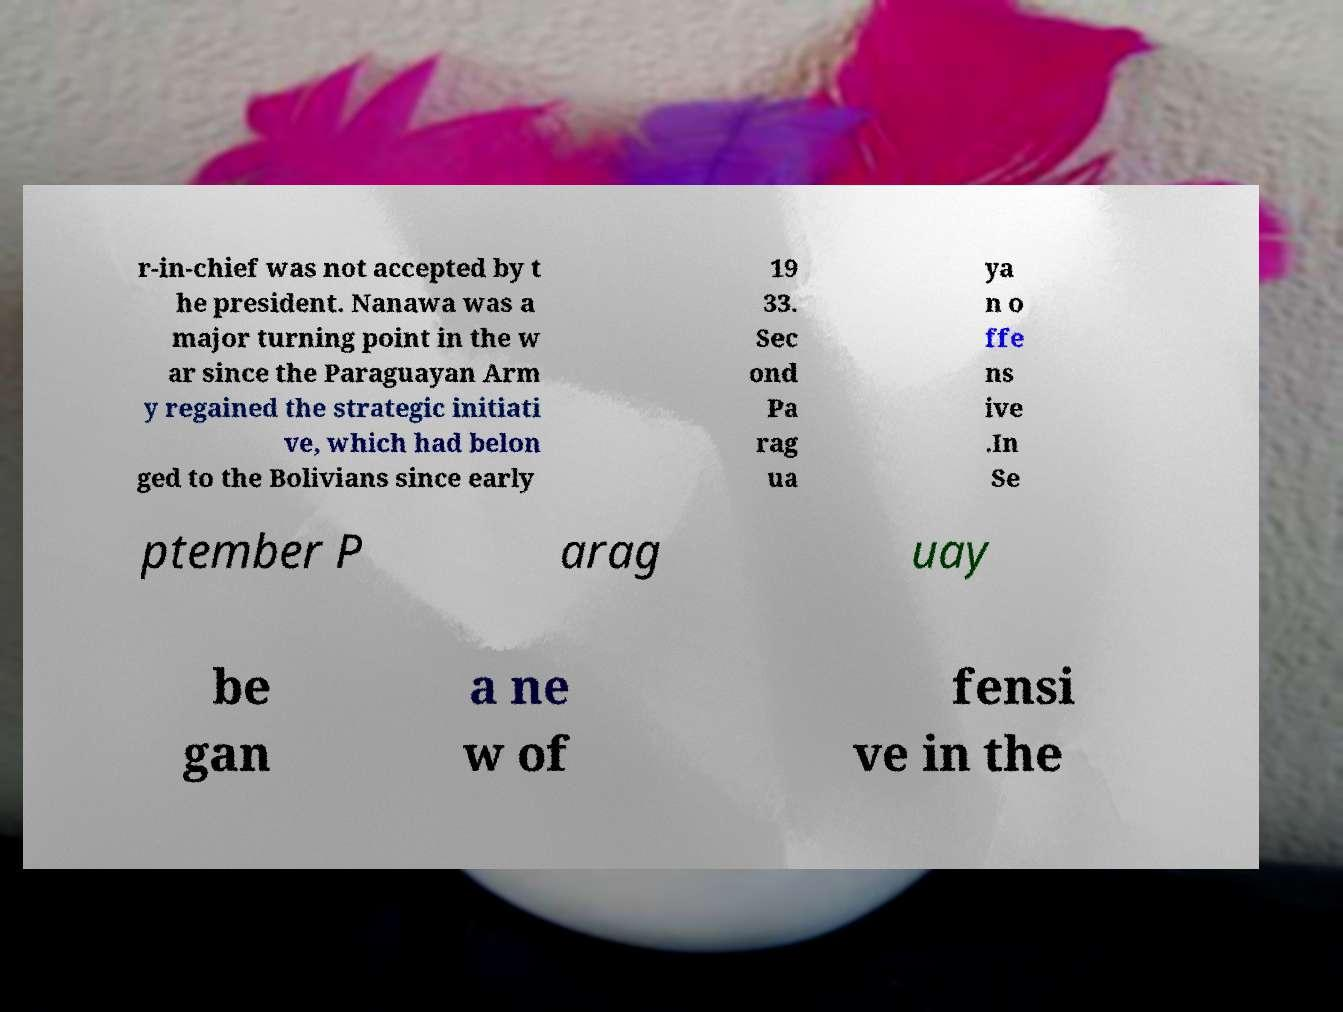Could you assist in decoding the text presented in this image and type it out clearly? r-in-chief was not accepted by t he president. Nanawa was a major turning point in the w ar since the Paraguayan Arm y regained the strategic initiati ve, which had belon ged to the Bolivians since early 19 33. Sec ond Pa rag ua ya n o ffe ns ive .In Se ptember P arag uay be gan a ne w of fensi ve in the 